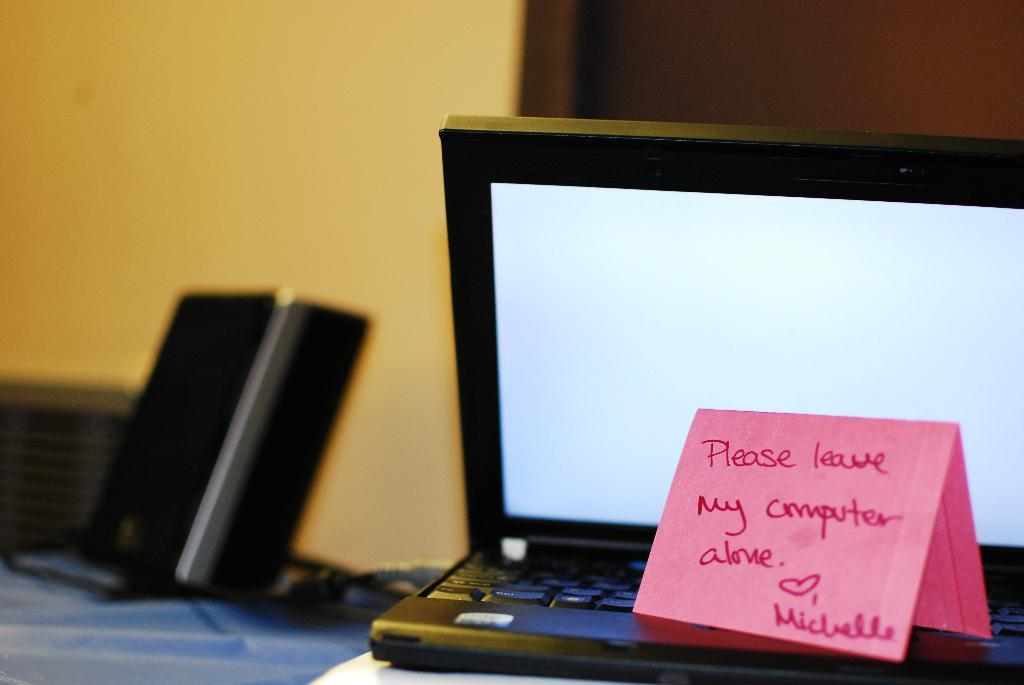<image>
Give a short and clear explanation of the subsequent image. Laptop with a note on it that says "Please leave my computer alone". 